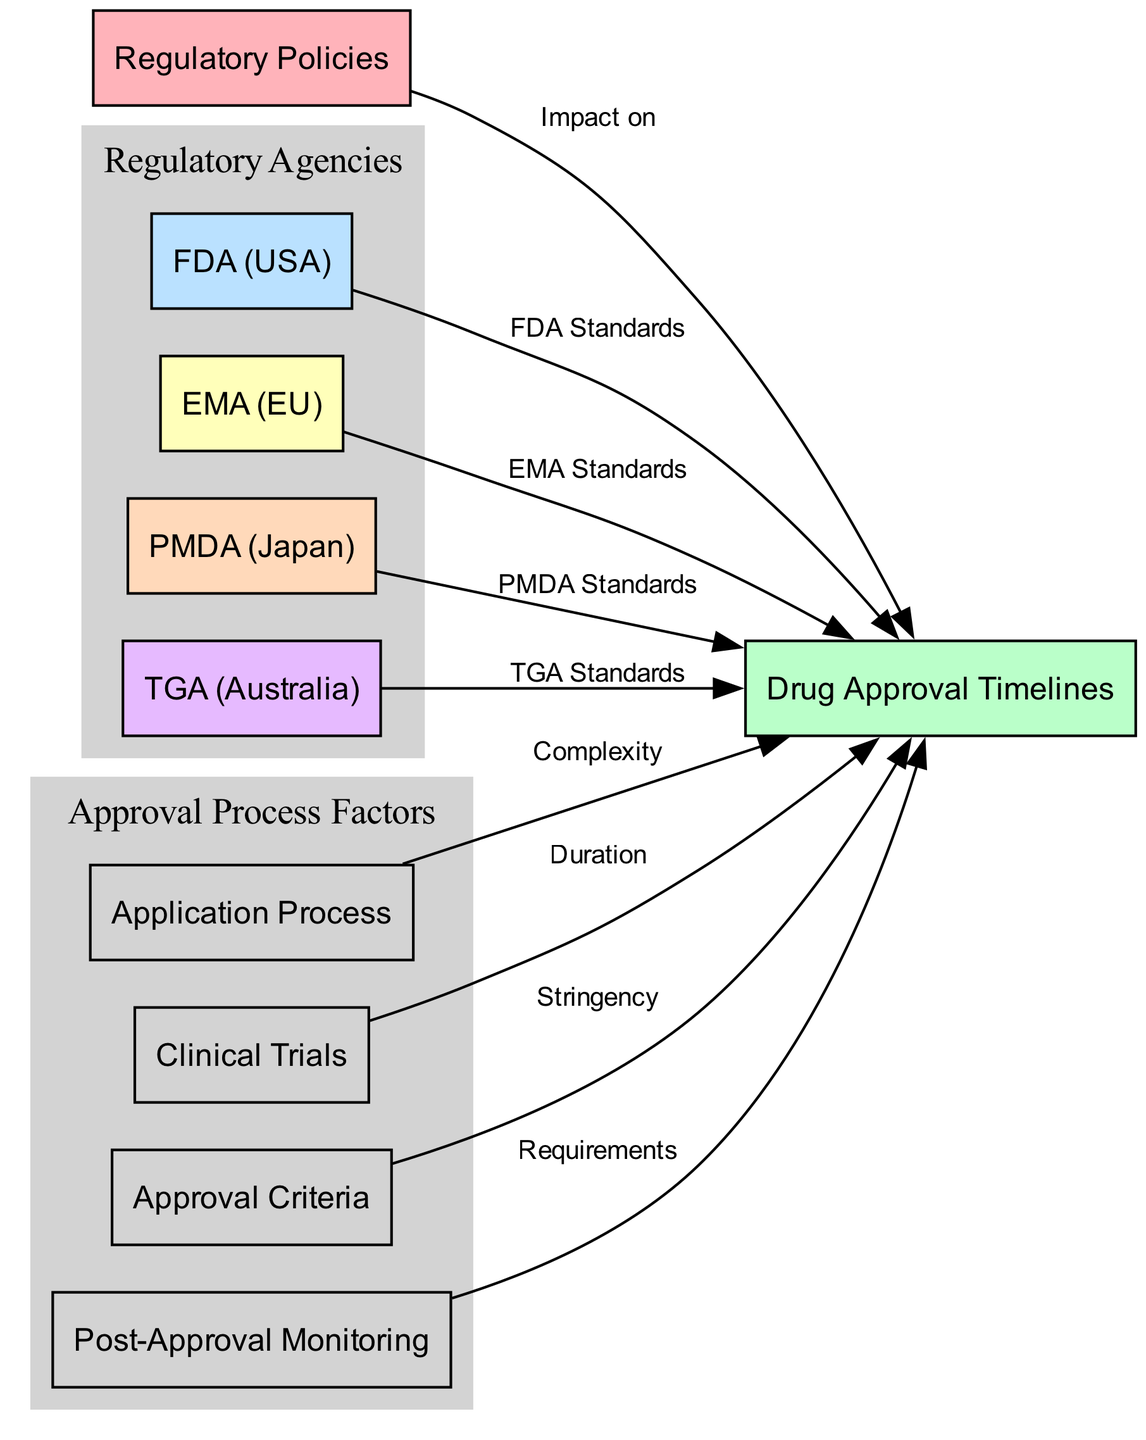What are the main regulatory agencies shown in the diagram? The diagram includes four regulatory agencies: FDA (USA), EMA (EU), PMDA (Japan), and TGA (Australia), as represented by specific nodes.
Answer: FDA, EMA, PMDA, TGA How many nodes are there in the diagram? By counting the unique nodes listed, there are a total of 9 nodes present in the diagram.
Answer: 9 What is the relationship labeled between regulatory policies and drug approval timelines? The edge between these two nodes is labeled "Impact on," indicating that regulatory policies affect the drug approval timelines.
Answer: Impact on Which regulatory agency's standards specifically impact drug approval timelines last in the flow? In the flow of connections shown in the diagram, TGA (Australia) is the last specified regulatory agency referencing its standards impacting drug approval timelines.
Answer: TGA What factor is linked to drug approval timelines by complexity? The node "application process" is connected to "drug approval timelines" with the label "Complexity," indicating its association.
Answer: Application Process Which aspect of the application process factors is connected to drug approval timelines? The node "clinical trials" is linked to "drug approval timelines" and describes their connection through the label "Duration."
Answer: Clinical Trials What is the approval criteria's effect on drug approval timelines? The approval criteria directly link to drug approval timelines with the edge labeled "Stringency," indicating that its strictness influences the timelines for approvals.
Answer: Stringency Which monitoring requirement follows drug approval timelines, according to the diagram? The diagram indicates that "Post-Approval Monitoring" has a direct edge towards "drug approval timelines," marked by the label "Requirements," showing its subsequent monitoring role.
Answer: Post-Approval Monitoring How many factors in total are connected to drug approval timelines from the application process? There are three nodes linked to drug approval timelines stemming from the application process: application process, clinical trials, and approval criteria.
Answer: 3 